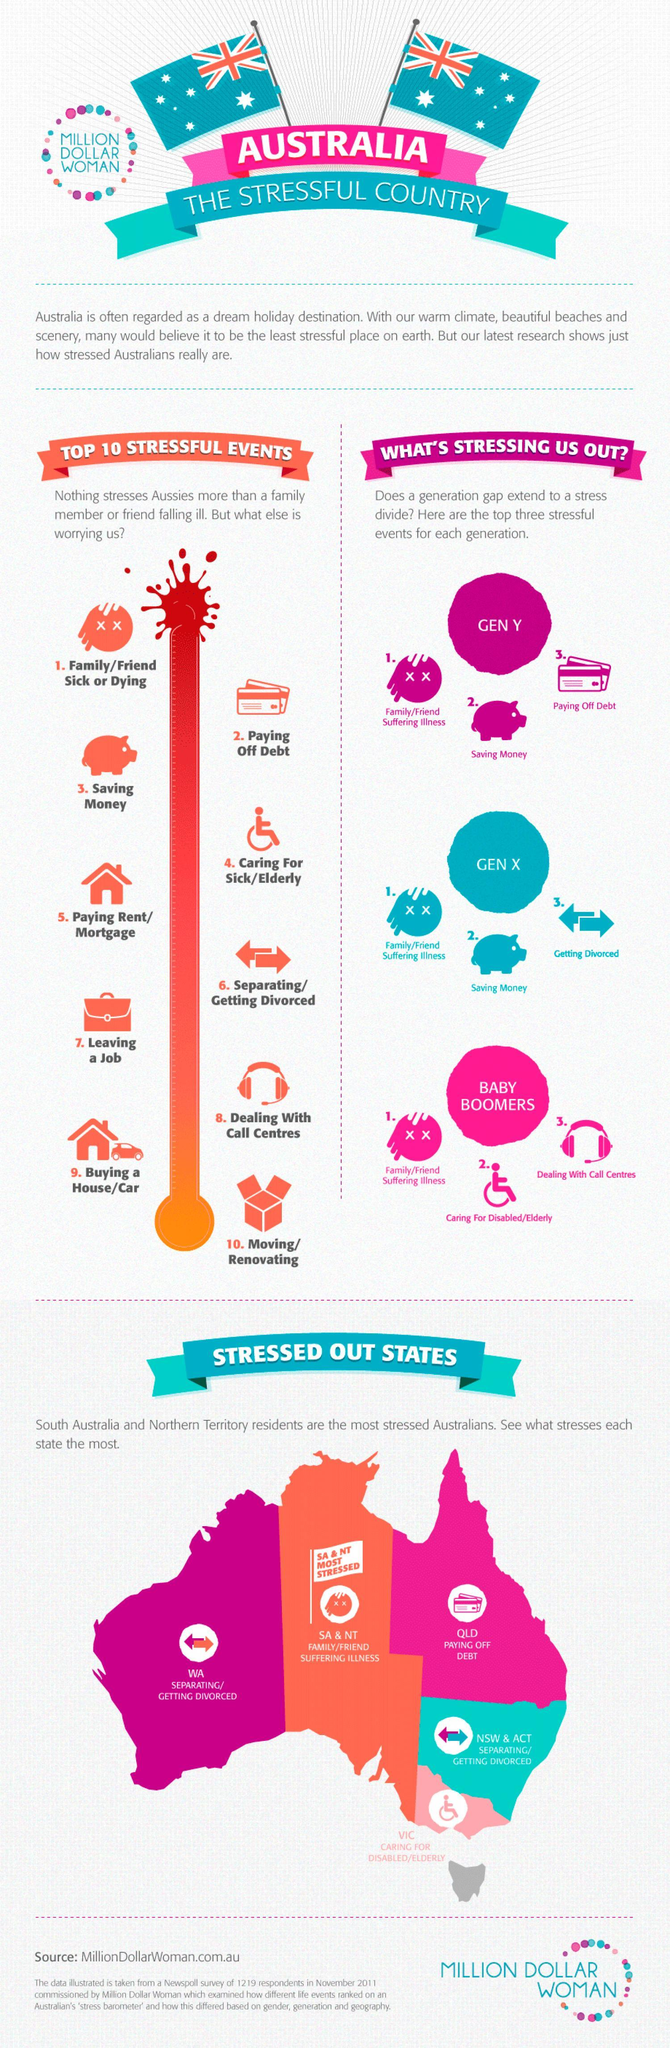What is written inside the dark pink circle Gen X, Baby Boomers or Gen Y?
Answer the question with a short phrase. Gen Y What is written inside the light pink circle  Gen Y, Baby Boomers or Gen X ? Baby Boomers How many stressed out states are there in Australia? 5 What is written inside the blue circle, Gen Y, Gen X, or Baby Boomers ? Gen X 